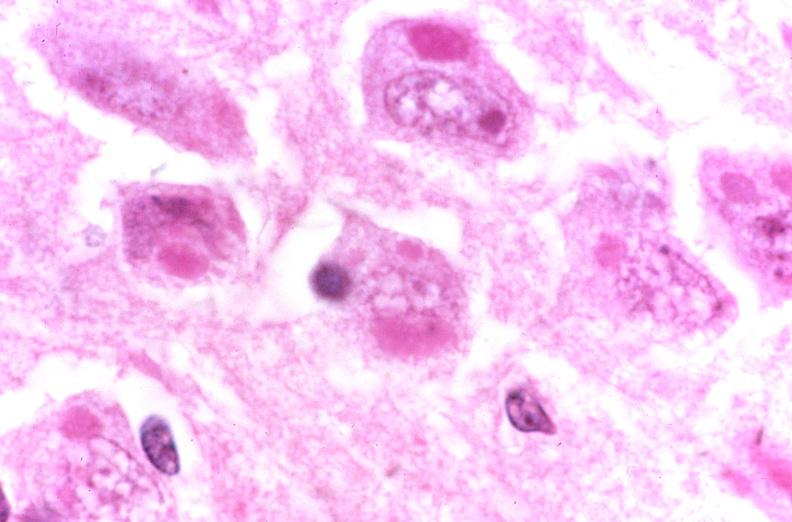does myocardial infarct show brain, rabies, inclusion dodies negri bodies?
Answer the question using a single word or phrase. No 